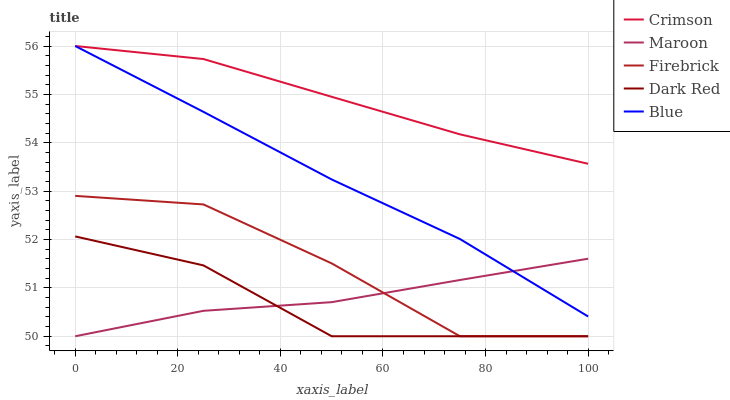Does Dark Red have the minimum area under the curve?
Answer yes or no. Yes. Does Crimson have the maximum area under the curve?
Answer yes or no. Yes. Does Firebrick have the minimum area under the curve?
Answer yes or no. No. Does Firebrick have the maximum area under the curve?
Answer yes or no. No. Is Blue the smoothest?
Answer yes or no. Yes. Is Firebrick the roughest?
Answer yes or no. Yes. Is Dark Red the smoothest?
Answer yes or no. No. Is Dark Red the roughest?
Answer yes or no. No. Does Blue have the lowest value?
Answer yes or no. No. Does Dark Red have the highest value?
Answer yes or no. No. Is Firebrick less than Blue?
Answer yes or no. Yes. Is Crimson greater than Dark Red?
Answer yes or no. Yes. Does Firebrick intersect Blue?
Answer yes or no. No. 